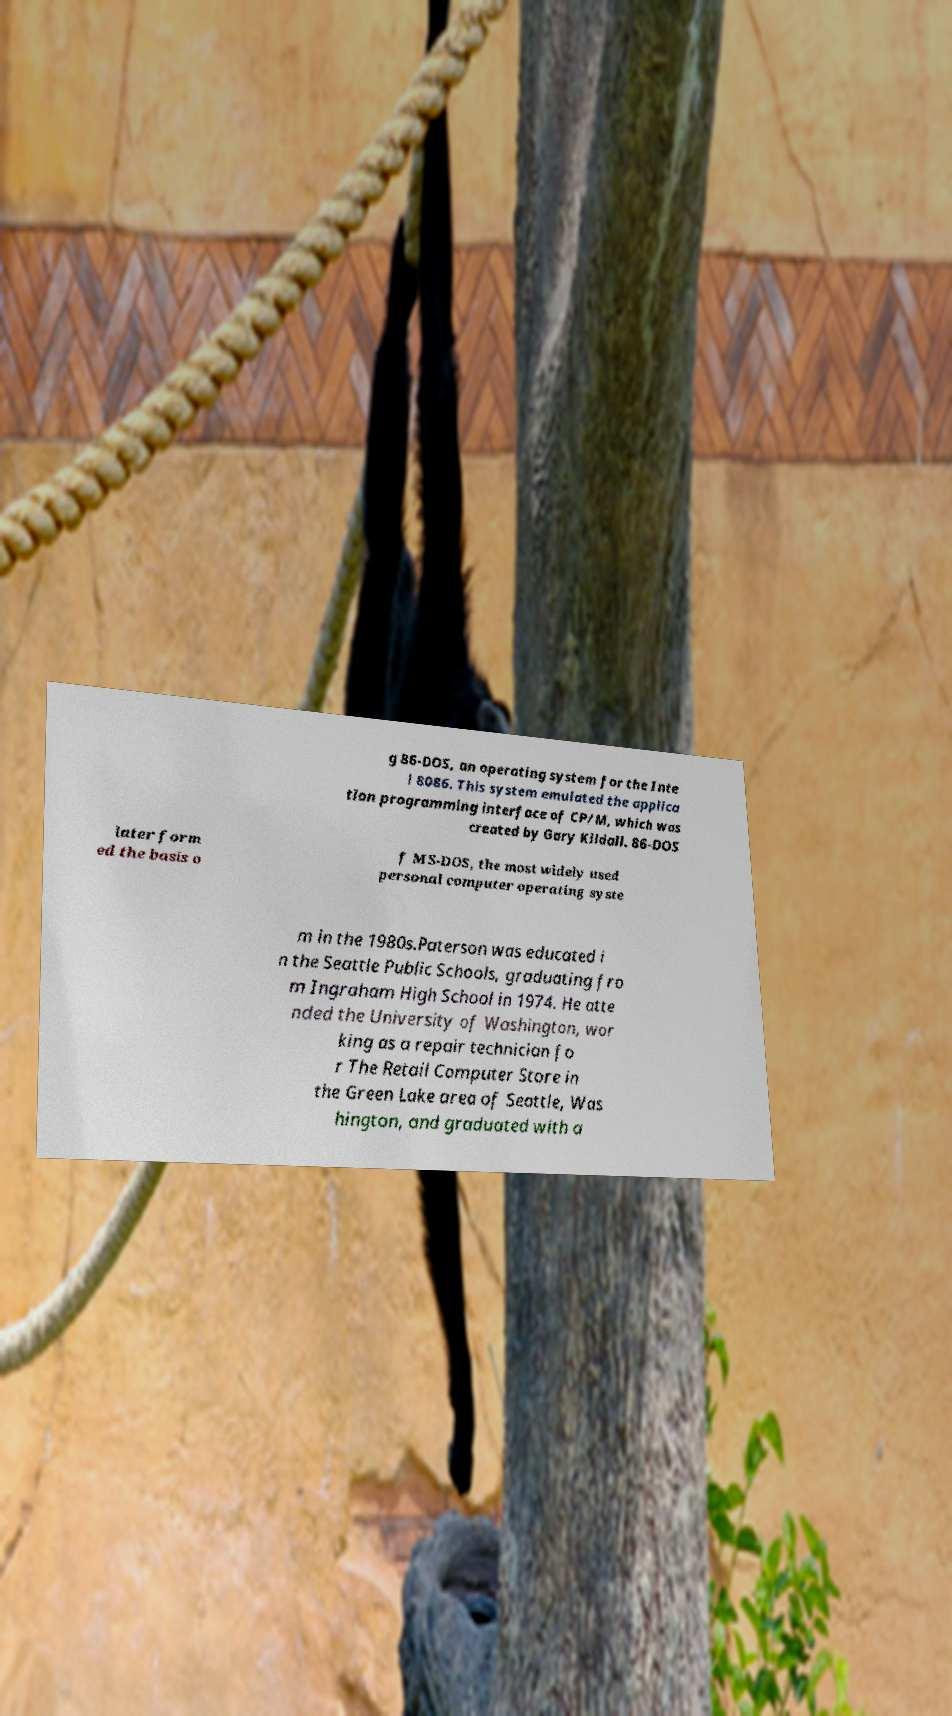Can you accurately transcribe the text from the provided image for me? g 86-DOS, an operating system for the Inte l 8086. This system emulated the applica tion programming interface of CP/M, which was created by Gary Kildall. 86-DOS later form ed the basis o f MS-DOS, the most widely used personal computer operating syste m in the 1980s.Paterson was educated i n the Seattle Public Schools, graduating fro m Ingraham High School in 1974. He atte nded the University of Washington, wor king as a repair technician fo r The Retail Computer Store in the Green Lake area of Seattle, Was hington, and graduated with a 